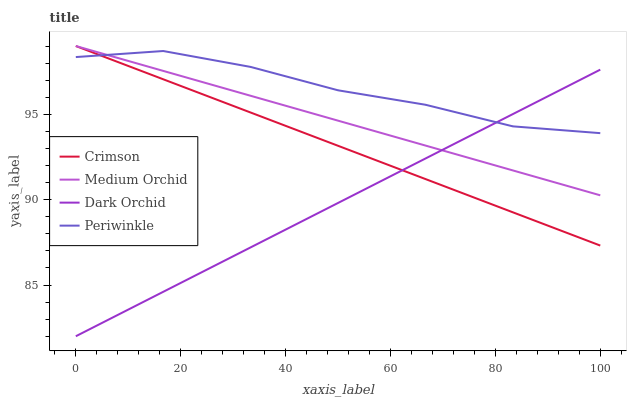Does Dark Orchid have the minimum area under the curve?
Answer yes or no. Yes. Does Periwinkle have the maximum area under the curve?
Answer yes or no. Yes. Does Medium Orchid have the minimum area under the curve?
Answer yes or no. No. Does Medium Orchid have the maximum area under the curve?
Answer yes or no. No. Is Dark Orchid the smoothest?
Answer yes or no. Yes. Is Periwinkle the roughest?
Answer yes or no. Yes. Is Medium Orchid the smoothest?
Answer yes or no. No. Is Medium Orchid the roughest?
Answer yes or no. No. Does Dark Orchid have the lowest value?
Answer yes or no. Yes. Does Medium Orchid have the lowest value?
Answer yes or no. No. Does Medium Orchid have the highest value?
Answer yes or no. Yes. Does Periwinkle have the highest value?
Answer yes or no. No. Does Dark Orchid intersect Crimson?
Answer yes or no. Yes. Is Dark Orchid less than Crimson?
Answer yes or no. No. Is Dark Orchid greater than Crimson?
Answer yes or no. No. 